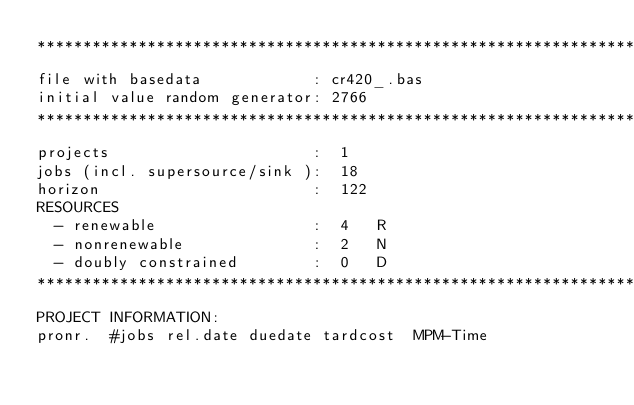<code> <loc_0><loc_0><loc_500><loc_500><_ObjectiveC_>************************************************************************
file with basedata            : cr420_.bas
initial value random generator: 2766
************************************************************************
projects                      :  1
jobs (incl. supersource/sink ):  18
horizon                       :  122
RESOURCES
  - renewable                 :  4   R
  - nonrenewable              :  2   N
  - doubly constrained        :  0   D
************************************************************************
PROJECT INFORMATION:
pronr.  #jobs rel.date duedate tardcost  MPM-Time</code> 